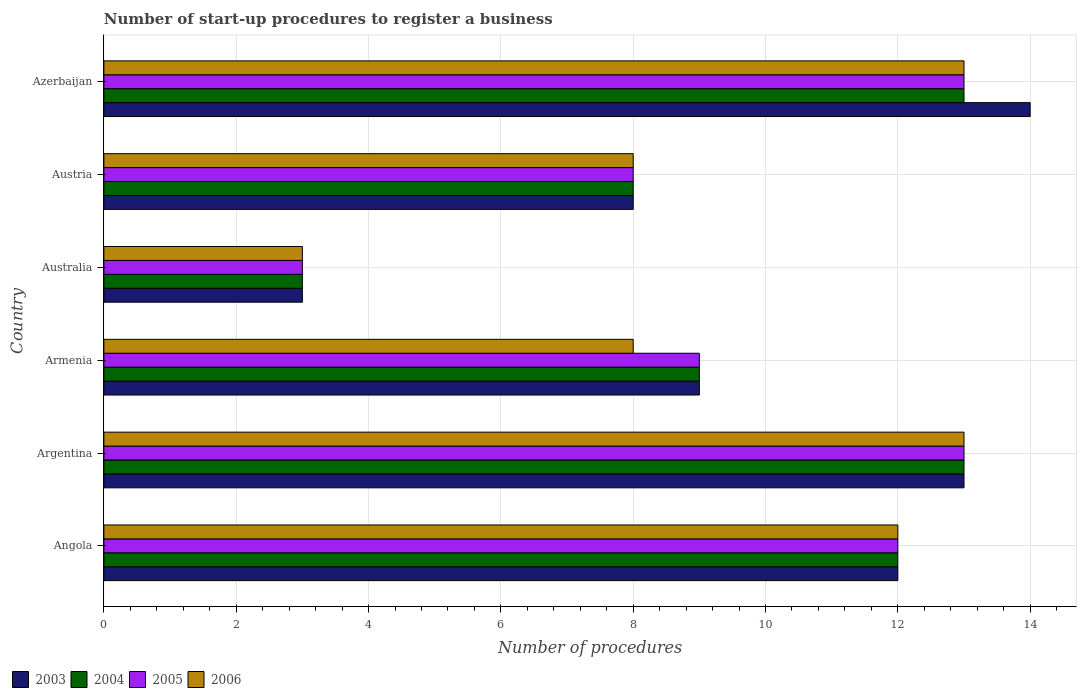How many different coloured bars are there?
Provide a succinct answer. 4. Are the number of bars per tick equal to the number of legend labels?
Your response must be concise. Yes. How many bars are there on the 3rd tick from the top?
Provide a succinct answer. 4. How many bars are there on the 6th tick from the bottom?
Give a very brief answer. 4. In which country was the number of procedures required to register a business in 2003 minimum?
Offer a terse response. Australia. What is the total number of procedures required to register a business in 2004 in the graph?
Make the answer very short. 58. What is the difference between the number of procedures required to register a business in 2005 in Argentina and that in Australia?
Provide a short and direct response. 10. What is the difference between the number of procedures required to register a business in 2003 in Azerbaijan and the number of procedures required to register a business in 2005 in Angola?
Your response must be concise. 2. What is the average number of procedures required to register a business in 2005 per country?
Provide a short and direct response. 9.67. In how many countries, is the number of procedures required to register a business in 2003 greater than 3.2 ?
Give a very brief answer. 5. What is the ratio of the number of procedures required to register a business in 2006 in Angola to that in Argentina?
Your answer should be very brief. 0.92. Is the difference between the number of procedures required to register a business in 2006 in Austria and Azerbaijan greater than the difference between the number of procedures required to register a business in 2003 in Austria and Azerbaijan?
Ensure brevity in your answer.  Yes. What is the difference between the highest and the second highest number of procedures required to register a business in 2003?
Offer a very short reply. 1. What is the difference between the highest and the lowest number of procedures required to register a business in 2005?
Keep it short and to the point. 10. Is it the case that in every country, the sum of the number of procedures required to register a business in 2005 and number of procedures required to register a business in 2003 is greater than the sum of number of procedures required to register a business in 2004 and number of procedures required to register a business in 2006?
Offer a terse response. No. What does the 3rd bar from the top in Austria represents?
Your answer should be compact. 2004. Are the values on the major ticks of X-axis written in scientific E-notation?
Make the answer very short. No. Does the graph contain grids?
Offer a terse response. Yes. How are the legend labels stacked?
Make the answer very short. Horizontal. What is the title of the graph?
Ensure brevity in your answer.  Number of start-up procedures to register a business. Does "1980" appear as one of the legend labels in the graph?
Your answer should be compact. No. What is the label or title of the X-axis?
Keep it short and to the point. Number of procedures. What is the label or title of the Y-axis?
Make the answer very short. Country. What is the Number of procedures of 2003 in Angola?
Provide a succinct answer. 12. What is the Number of procedures in 2006 in Angola?
Give a very brief answer. 12. What is the Number of procedures in 2003 in Argentina?
Make the answer very short. 13. What is the Number of procedures in 2005 in Argentina?
Provide a short and direct response. 13. What is the Number of procedures of 2006 in Australia?
Offer a terse response. 3. What is the Number of procedures of 2003 in Austria?
Offer a very short reply. 8. What is the Number of procedures of 2004 in Austria?
Offer a terse response. 8. What is the Number of procedures of 2005 in Austria?
Offer a very short reply. 8. What is the Number of procedures in 2006 in Austria?
Your answer should be compact. 8. What is the Number of procedures in 2004 in Azerbaijan?
Provide a short and direct response. 13. What is the Number of procedures in 2006 in Azerbaijan?
Ensure brevity in your answer.  13. Across all countries, what is the maximum Number of procedures of 2003?
Provide a short and direct response. 14. Across all countries, what is the maximum Number of procedures in 2004?
Give a very brief answer. 13. Across all countries, what is the maximum Number of procedures in 2005?
Your answer should be very brief. 13. Across all countries, what is the maximum Number of procedures of 2006?
Your answer should be compact. 13. Across all countries, what is the minimum Number of procedures of 2003?
Provide a succinct answer. 3. Across all countries, what is the minimum Number of procedures in 2005?
Keep it short and to the point. 3. What is the difference between the Number of procedures in 2003 in Angola and that in Argentina?
Keep it short and to the point. -1. What is the difference between the Number of procedures in 2004 in Angola and that in Argentina?
Your response must be concise. -1. What is the difference between the Number of procedures in 2005 in Angola and that in Argentina?
Offer a very short reply. -1. What is the difference between the Number of procedures in 2003 in Angola and that in Armenia?
Your answer should be compact. 3. What is the difference between the Number of procedures of 2006 in Angola and that in Armenia?
Your response must be concise. 4. What is the difference between the Number of procedures in 2003 in Angola and that in Australia?
Provide a succinct answer. 9. What is the difference between the Number of procedures in 2003 in Angola and that in Austria?
Offer a very short reply. 4. What is the difference between the Number of procedures in 2006 in Angola and that in Austria?
Your answer should be very brief. 4. What is the difference between the Number of procedures in 2003 in Angola and that in Azerbaijan?
Give a very brief answer. -2. What is the difference between the Number of procedures of 2004 in Angola and that in Azerbaijan?
Offer a very short reply. -1. What is the difference between the Number of procedures of 2006 in Angola and that in Azerbaijan?
Your answer should be compact. -1. What is the difference between the Number of procedures of 2004 in Argentina and that in Armenia?
Give a very brief answer. 4. What is the difference between the Number of procedures of 2005 in Argentina and that in Armenia?
Your answer should be compact. 4. What is the difference between the Number of procedures in 2004 in Argentina and that in Australia?
Your response must be concise. 10. What is the difference between the Number of procedures in 2005 in Argentina and that in Australia?
Make the answer very short. 10. What is the difference between the Number of procedures in 2003 in Argentina and that in Austria?
Offer a very short reply. 5. What is the difference between the Number of procedures in 2004 in Argentina and that in Austria?
Your answer should be compact. 5. What is the difference between the Number of procedures of 2005 in Argentina and that in Austria?
Give a very brief answer. 5. What is the difference between the Number of procedures in 2004 in Argentina and that in Azerbaijan?
Offer a very short reply. 0. What is the difference between the Number of procedures of 2006 in Argentina and that in Azerbaijan?
Your response must be concise. 0. What is the difference between the Number of procedures in 2006 in Armenia and that in Australia?
Ensure brevity in your answer.  5. What is the difference between the Number of procedures in 2005 in Armenia and that in Austria?
Your answer should be very brief. 1. What is the difference between the Number of procedures of 2004 in Armenia and that in Azerbaijan?
Keep it short and to the point. -4. What is the difference between the Number of procedures of 2005 in Armenia and that in Azerbaijan?
Ensure brevity in your answer.  -4. What is the difference between the Number of procedures in 2006 in Australia and that in Austria?
Make the answer very short. -5. What is the difference between the Number of procedures in 2003 in Australia and that in Azerbaijan?
Your response must be concise. -11. What is the difference between the Number of procedures in 2004 in Australia and that in Azerbaijan?
Your answer should be very brief. -10. What is the difference between the Number of procedures of 2004 in Austria and that in Azerbaijan?
Ensure brevity in your answer.  -5. What is the difference between the Number of procedures in 2005 in Austria and that in Azerbaijan?
Offer a terse response. -5. What is the difference between the Number of procedures in 2003 in Angola and the Number of procedures in 2004 in Argentina?
Provide a short and direct response. -1. What is the difference between the Number of procedures of 2003 in Angola and the Number of procedures of 2005 in Argentina?
Make the answer very short. -1. What is the difference between the Number of procedures in 2003 in Angola and the Number of procedures in 2006 in Argentina?
Make the answer very short. -1. What is the difference between the Number of procedures of 2004 in Angola and the Number of procedures of 2006 in Argentina?
Your answer should be very brief. -1. What is the difference between the Number of procedures of 2004 in Angola and the Number of procedures of 2006 in Armenia?
Provide a succinct answer. 4. What is the difference between the Number of procedures in 2005 in Angola and the Number of procedures in 2006 in Armenia?
Make the answer very short. 4. What is the difference between the Number of procedures of 2003 in Angola and the Number of procedures of 2006 in Australia?
Your answer should be very brief. 9. What is the difference between the Number of procedures in 2004 in Angola and the Number of procedures in 2005 in Australia?
Your answer should be compact. 9. What is the difference between the Number of procedures in 2004 in Angola and the Number of procedures in 2006 in Australia?
Make the answer very short. 9. What is the difference between the Number of procedures of 2005 in Angola and the Number of procedures of 2006 in Australia?
Keep it short and to the point. 9. What is the difference between the Number of procedures in 2003 in Angola and the Number of procedures in 2004 in Austria?
Offer a very short reply. 4. What is the difference between the Number of procedures of 2003 in Angola and the Number of procedures of 2005 in Austria?
Your answer should be very brief. 4. What is the difference between the Number of procedures in 2003 in Angola and the Number of procedures in 2006 in Austria?
Make the answer very short. 4. What is the difference between the Number of procedures of 2004 in Angola and the Number of procedures of 2005 in Austria?
Give a very brief answer. 4. What is the difference between the Number of procedures in 2004 in Angola and the Number of procedures in 2006 in Austria?
Make the answer very short. 4. What is the difference between the Number of procedures in 2003 in Angola and the Number of procedures in 2004 in Azerbaijan?
Give a very brief answer. -1. What is the difference between the Number of procedures in 2003 in Angola and the Number of procedures in 2006 in Azerbaijan?
Provide a short and direct response. -1. What is the difference between the Number of procedures in 2004 in Angola and the Number of procedures in 2005 in Azerbaijan?
Ensure brevity in your answer.  -1. What is the difference between the Number of procedures in 2003 in Argentina and the Number of procedures in 2004 in Armenia?
Your answer should be very brief. 4. What is the difference between the Number of procedures in 2005 in Argentina and the Number of procedures in 2006 in Armenia?
Make the answer very short. 5. What is the difference between the Number of procedures of 2003 in Argentina and the Number of procedures of 2006 in Australia?
Keep it short and to the point. 10. What is the difference between the Number of procedures of 2005 in Argentina and the Number of procedures of 2006 in Australia?
Keep it short and to the point. 10. What is the difference between the Number of procedures in 2003 in Argentina and the Number of procedures in 2004 in Austria?
Your answer should be very brief. 5. What is the difference between the Number of procedures in 2003 in Argentina and the Number of procedures in 2005 in Austria?
Your answer should be very brief. 5. What is the difference between the Number of procedures of 2003 in Argentina and the Number of procedures of 2006 in Austria?
Your answer should be compact. 5. What is the difference between the Number of procedures of 2004 in Argentina and the Number of procedures of 2006 in Austria?
Provide a short and direct response. 5. What is the difference between the Number of procedures of 2005 in Argentina and the Number of procedures of 2006 in Austria?
Offer a terse response. 5. What is the difference between the Number of procedures of 2003 in Argentina and the Number of procedures of 2004 in Azerbaijan?
Your answer should be compact. 0. What is the difference between the Number of procedures in 2003 in Argentina and the Number of procedures in 2006 in Azerbaijan?
Keep it short and to the point. 0. What is the difference between the Number of procedures of 2004 in Argentina and the Number of procedures of 2006 in Azerbaijan?
Your answer should be compact. 0. What is the difference between the Number of procedures in 2003 in Armenia and the Number of procedures in 2005 in Australia?
Ensure brevity in your answer.  6. What is the difference between the Number of procedures of 2003 in Armenia and the Number of procedures of 2006 in Australia?
Your response must be concise. 6. What is the difference between the Number of procedures of 2005 in Armenia and the Number of procedures of 2006 in Australia?
Offer a very short reply. 6. What is the difference between the Number of procedures in 2003 in Armenia and the Number of procedures in 2004 in Austria?
Give a very brief answer. 1. What is the difference between the Number of procedures of 2005 in Armenia and the Number of procedures of 2006 in Austria?
Make the answer very short. 1. What is the difference between the Number of procedures of 2003 in Armenia and the Number of procedures of 2005 in Azerbaijan?
Provide a succinct answer. -4. What is the difference between the Number of procedures in 2003 in Armenia and the Number of procedures in 2006 in Azerbaijan?
Your answer should be compact. -4. What is the difference between the Number of procedures of 2004 in Armenia and the Number of procedures of 2005 in Azerbaijan?
Your response must be concise. -4. What is the difference between the Number of procedures in 2004 in Armenia and the Number of procedures in 2006 in Azerbaijan?
Your response must be concise. -4. What is the difference between the Number of procedures of 2005 in Armenia and the Number of procedures of 2006 in Azerbaijan?
Offer a terse response. -4. What is the difference between the Number of procedures of 2003 in Australia and the Number of procedures of 2004 in Austria?
Make the answer very short. -5. What is the difference between the Number of procedures of 2003 in Australia and the Number of procedures of 2006 in Austria?
Your answer should be compact. -5. What is the difference between the Number of procedures in 2004 in Australia and the Number of procedures in 2006 in Austria?
Your answer should be very brief. -5. What is the difference between the Number of procedures of 2005 in Australia and the Number of procedures of 2006 in Austria?
Provide a succinct answer. -5. What is the difference between the Number of procedures in 2003 in Australia and the Number of procedures in 2005 in Azerbaijan?
Keep it short and to the point. -10. What is the difference between the Number of procedures in 2003 in Australia and the Number of procedures in 2006 in Azerbaijan?
Your answer should be compact. -10. What is the difference between the Number of procedures in 2004 in Australia and the Number of procedures in 2005 in Azerbaijan?
Your answer should be very brief. -10. What is the difference between the Number of procedures of 2005 in Australia and the Number of procedures of 2006 in Azerbaijan?
Give a very brief answer. -10. What is the difference between the Number of procedures in 2003 in Austria and the Number of procedures in 2005 in Azerbaijan?
Offer a terse response. -5. What is the difference between the Number of procedures in 2003 in Austria and the Number of procedures in 2006 in Azerbaijan?
Provide a succinct answer. -5. What is the difference between the Number of procedures in 2004 in Austria and the Number of procedures in 2005 in Azerbaijan?
Your answer should be compact. -5. What is the difference between the Number of procedures of 2004 in Austria and the Number of procedures of 2006 in Azerbaijan?
Offer a very short reply. -5. What is the difference between the Number of procedures of 2005 in Austria and the Number of procedures of 2006 in Azerbaijan?
Your answer should be very brief. -5. What is the average Number of procedures of 2003 per country?
Keep it short and to the point. 9.83. What is the average Number of procedures in 2004 per country?
Provide a succinct answer. 9.67. What is the average Number of procedures of 2005 per country?
Give a very brief answer. 9.67. What is the difference between the Number of procedures of 2003 and Number of procedures of 2004 in Angola?
Provide a succinct answer. 0. What is the difference between the Number of procedures of 2003 and Number of procedures of 2004 in Argentina?
Your answer should be very brief. 0. What is the difference between the Number of procedures in 2003 and Number of procedures in 2005 in Argentina?
Give a very brief answer. 0. What is the difference between the Number of procedures of 2005 and Number of procedures of 2006 in Argentina?
Offer a terse response. 0. What is the difference between the Number of procedures of 2003 and Number of procedures of 2005 in Armenia?
Ensure brevity in your answer.  0. What is the difference between the Number of procedures in 2004 and Number of procedures in 2005 in Armenia?
Provide a short and direct response. 0. What is the difference between the Number of procedures in 2004 and Number of procedures in 2006 in Armenia?
Your response must be concise. 1. What is the difference between the Number of procedures in 2003 and Number of procedures in 2004 in Australia?
Your answer should be compact. 0. What is the difference between the Number of procedures of 2004 and Number of procedures of 2006 in Australia?
Make the answer very short. 0. What is the difference between the Number of procedures in 2005 and Number of procedures in 2006 in Australia?
Give a very brief answer. 0. What is the difference between the Number of procedures of 2005 and Number of procedures of 2006 in Austria?
Offer a terse response. 0. What is the difference between the Number of procedures of 2003 and Number of procedures of 2005 in Azerbaijan?
Offer a terse response. 1. What is the difference between the Number of procedures in 2004 and Number of procedures in 2006 in Azerbaijan?
Offer a very short reply. 0. What is the difference between the Number of procedures of 2005 and Number of procedures of 2006 in Azerbaijan?
Keep it short and to the point. 0. What is the ratio of the Number of procedures of 2003 in Angola to that in Argentina?
Offer a terse response. 0.92. What is the ratio of the Number of procedures of 2006 in Angola to that in Argentina?
Your response must be concise. 0.92. What is the ratio of the Number of procedures of 2003 in Angola to that in Armenia?
Offer a very short reply. 1.33. What is the ratio of the Number of procedures of 2004 in Angola to that in Armenia?
Keep it short and to the point. 1.33. What is the ratio of the Number of procedures of 2005 in Angola to that in Armenia?
Offer a very short reply. 1.33. What is the ratio of the Number of procedures in 2003 in Angola to that in Australia?
Provide a short and direct response. 4. What is the ratio of the Number of procedures in 2004 in Angola to that in Austria?
Give a very brief answer. 1.5. What is the ratio of the Number of procedures of 2005 in Angola to that in Azerbaijan?
Offer a very short reply. 0.92. What is the ratio of the Number of procedures in 2006 in Angola to that in Azerbaijan?
Provide a succinct answer. 0.92. What is the ratio of the Number of procedures in 2003 in Argentina to that in Armenia?
Ensure brevity in your answer.  1.44. What is the ratio of the Number of procedures of 2004 in Argentina to that in Armenia?
Your response must be concise. 1.44. What is the ratio of the Number of procedures in 2005 in Argentina to that in Armenia?
Make the answer very short. 1.44. What is the ratio of the Number of procedures of 2006 in Argentina to that in Armenia?
Keep it short and to the point. 1.62. What is the ratio of the Number of procedures of 2003 in Argentina to that in Australia?
Provide a short and direct response. 4.33. What is the ratio of the Number of procedures in 2004 in Argentina to that in Australia?
Provide a short and direct response. 4.33. What is the ratio of the Number of procedures of 2005 in Argentina to that in Australia?
Give a very brief answer. 4.33. What is the ratio of the Number of procedures of 2006 in Argentina to that in Australia?
Your response must be concise. 4.33. What is the ratio of the Number of procedures in 2003 in Argentina to that in Austria?
Ensure brevity in your answer.  1.62. What is the ratio of the Number of procedures of 2004 in Argentina to that in Austria?
Ensure brevity in your answer.  1.62. What is the ratio of the Number of procedures in 2005 in Argentina to that in Austria?
Keep it short and to the point. 1.62. What is the ratio of the Number of procedures in 2006 in Argentina to that in Austria?
Give a very brief answer. 1.62. What is the ratio of the Number of procedures in 2003 in Argentina to that in Azerbaijan?
Give a very brief answer. 0.93. What is the ratio of the Number of procedures in 2003 in Armenia to that in Australia?
Your answer should be very brief. 3. What is the ratio of the Number of procedures of 2004 in Armenia to that in Australia?
Offer a terse response. 3. What is the ratio of the Number of procedures of 2005 in Armenia to that in Australia?
Offer a terse response. 3. What is the ratio of the Number of procedures of 2006 in Armenia to that in Australia?
Your answer should be compact. 2.67. What is the ratio of the Number of procedures in 2004 in Armenia to that in Austria?
Offer a very short reply. 1.12. What is the ratio of the Number of procedures of 2005 in Armenia to that in Austria?
Ensure brevity in your answer.  1.12. What is the ratio of the Number of procedures in 2003 in Armenia to that in Azerbaijan?
Provide a succinct answer. 0.64. What is the ratio of the Number of procedures of 2004 in Armenia to that in Azerbaijan?
Provide a short and direct response. 0.69. What is the ratio of the Number of procedures in 2005 in Armenia to that in Azerbaijan?
Make the answer very short. 0.69. What is the ratio of the Number of procedures in 2006 in Armenia to that in Azerbaijan?
Your response must be concise. 0.62. What is the ratio of the Number of procedures of 2003 in Australia to that in Austria?
Your response must be concise. 0.38. What is the ratio of the Number of procedures of 2005 in Australia to that in Austria?
Provide a succinct answer. 0.38. What is the ratio of the Number of procedures of 2006 in Australia to that in Austria?
Your response must be concise. 0.38. What is the ratio of the Number of procedures of 2003 in Australia to that in Azerbaijan?
Offer a very short reply. 0.21. What is the ratio of the Number of procedures in 2004 in Australia to that in Azerbaijan?
Make the answer very short. 0.23. What is the ratio of the Number of procedures of 2005 in Australia to that in Azerbaijan?
Provide a succinct answer. 0.23. What is the ratio of the Number of procedures in 2006 in Australia to that in Azerbaijan?
Keep it short and to the point. 0.23. What is the ratio of the Number of procedures in 2003 in Austria to that in Azerbaijan?
Offer a very short reply. 0.57. What is the ratio of the Number of procedures of 2004 in Austria to that in Azerbaijan?
Ensure brevity in your answer.  0.62. What is the ratio of the Number of procedures in 2005 in Austria to that in Azerbaijan?
Offer a terse response. 0.62. What is the ratio of the Number of procedures of 2006 in Austria to that in Azerbaijan?
Keep it short and to the point. 0.62. What is the difference between the highest and the second highest Number of procedures in 2004?
Provide a short and direct response. 0. What is the difference between the highest and the second highest Number of procedures in 2005?
Make the answer very short. 0. What is the difference between the highest and the second highest Number of procedures in 2006?
Give a very brief answer. 0. What is the difference between the highest and the lowest Number of procedures in 2003?
Keep it short and to the point. 11. 